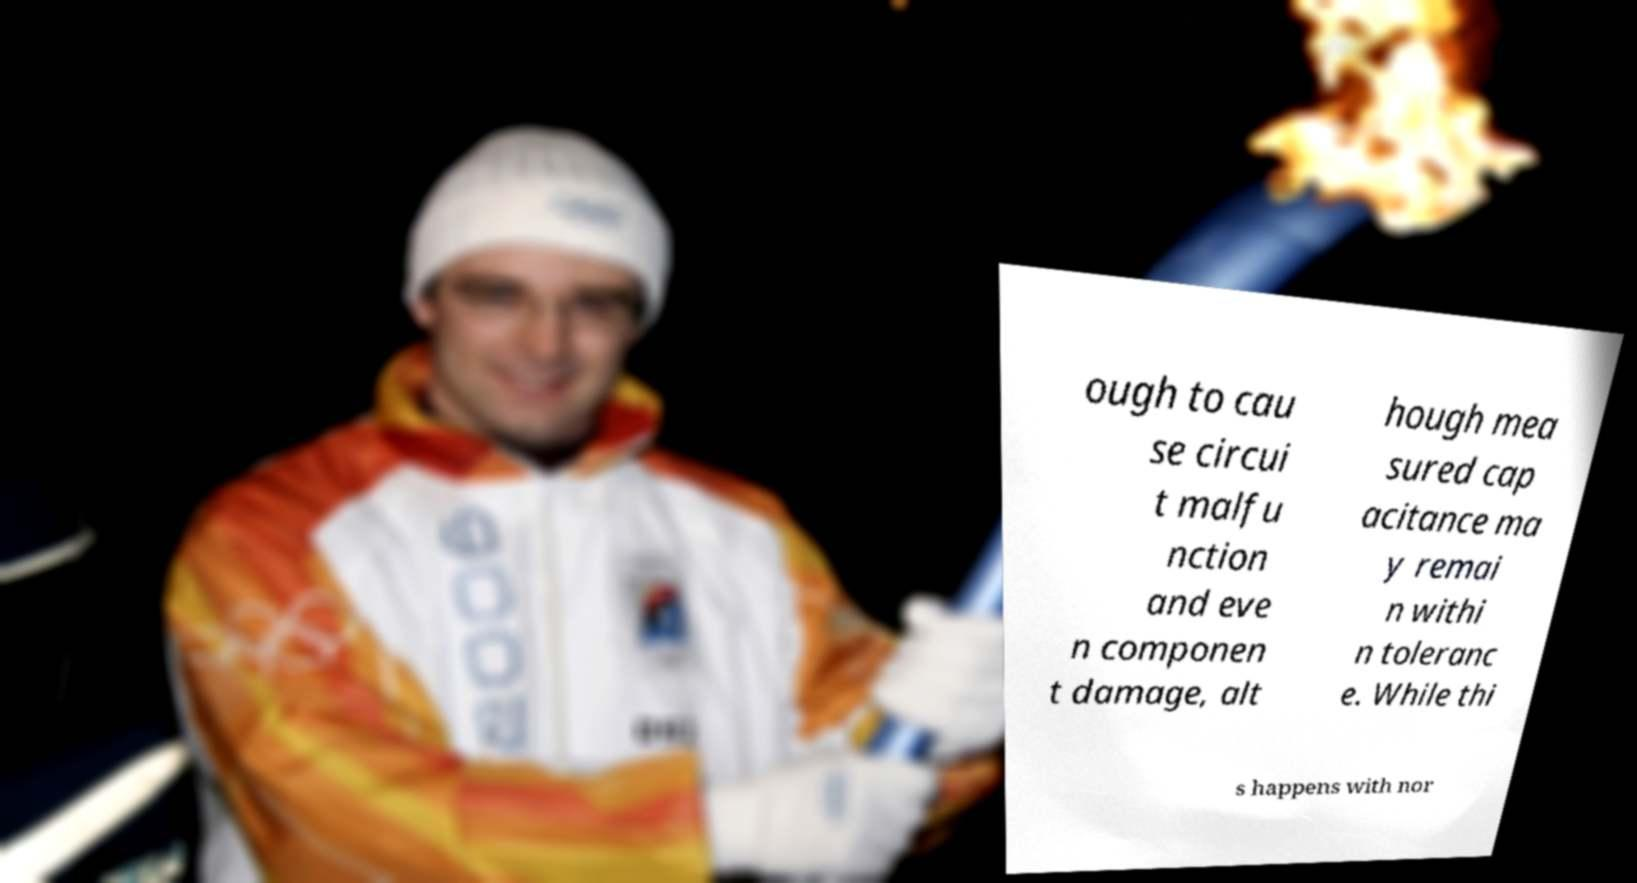Please identify and transcribe the text found in this image. ough to cau se circui t malfu nction and eve n componen t damage, alt hough mea sured cap acitance ma y remai n withi n toleranc e. While thi s happens with nor 